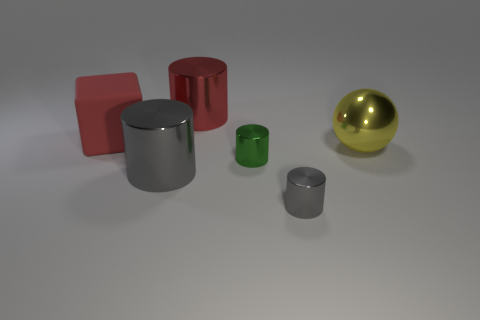Are any of the objects positioned in a way that suggests motion or activity? The objects are stationary and there's no clear indication of motion or activity. The arrangement is static, with each object resting on the surface without overlap or dynamic positioning that would suggest movement. 